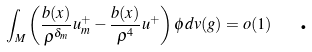<formula> <loc_0><loc_0><loc_500><loc_500>\int _ { M } \left ( \frac { b ( x ) } { \rho ^ { \delta _ { m } } } u _ { m } ^ { + } - \frac { b ( x ) } { \rho ^ { 4 } } u ^ { + } \right ) \phi d v ( g ) = o ( 1 ) \text { \ \ .}</formula> 